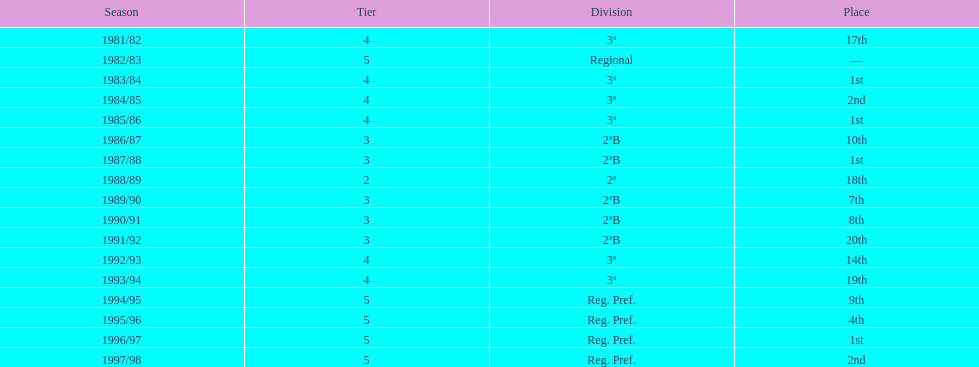Which year lacks a mentioned place? 1982/83. 